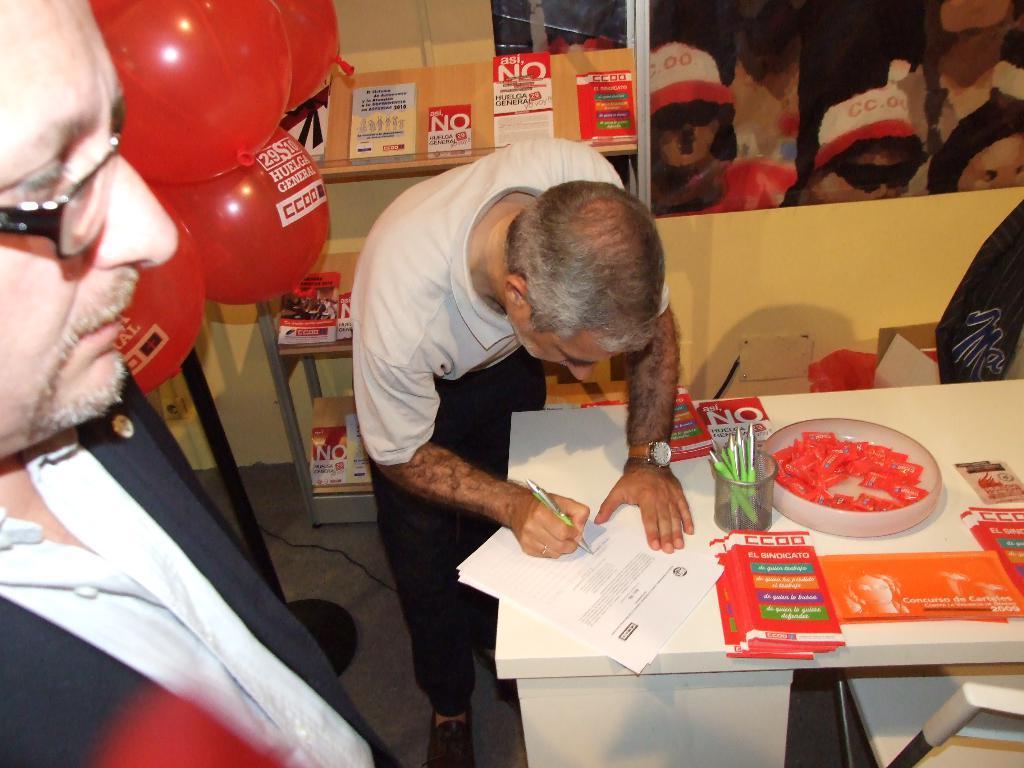In one or two sentences, can you explain what this image depicts? In the image we can see there are people wearing clothes. This is a spectacle, wrist watch, pen, papers, container, table, floor, cable wire, shelf and balloons. 